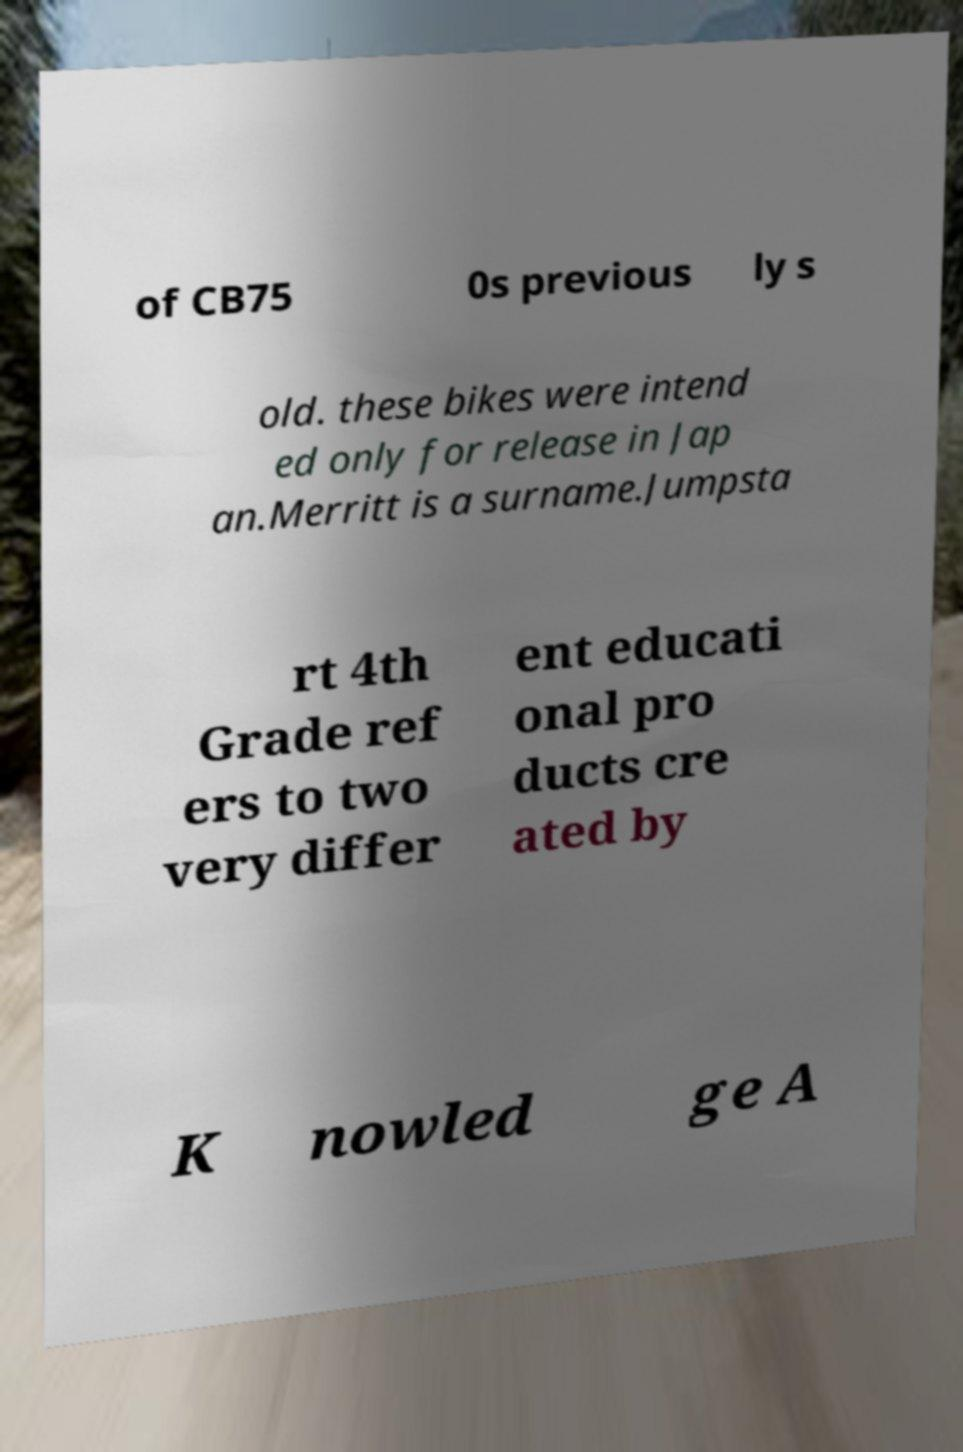Please identify and transcribe the text found in this image. of CB75 0s previous ly s old. these bikes were intend ed only for release in Jap an.Merritt is a surname.Jumpsta rt 4th Grade ref ers to two very differ ent educati onal pro ducts cre ated by K nowled ge A 